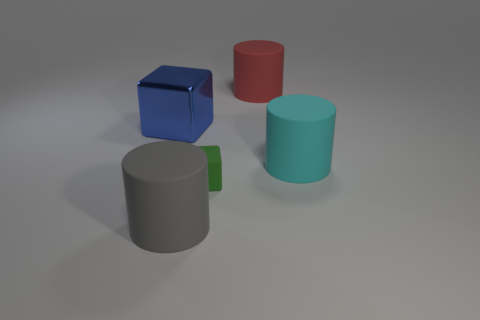There is a cylinder in front of the cyan rubber object; does it have the same size as the green matte cube?
Ensure brevity in your answer.  No. Are there any other rubber things of the same size as the gray matte object?
Your response must be concise. Yes. There is a block that is left of the large gray object; does it have the same color as the cube on the right side of the gray thing?
Give a very brief answer. No. Are there any big objects of the same color as the metallic cube?
Make the answer very short. No. What number of other objects are there of the same shape as the big blue object?
Ensure brevity in your answer.  1. There is a large rubber object that is in front of the big cyan rubber thing; what is its shape?
Provide a succinct answer. Cylinder. Does the blue metallic object have the same shape as the large rubber thing that is behind the big cyan rubber cylinder?
Offer a terse response. No. How big is the thing that is both left of the green matte thing and behind the cyan rubber thing?
Your response must be concise. Large. The big cylinder that is both on the left side of the big cyan cylinder and right of the gray rubber thing is what color?
Your answer should be compact. Red. Is there anything else that is the same material as the gray cylinder?
Offer a very short reply. Yes. 